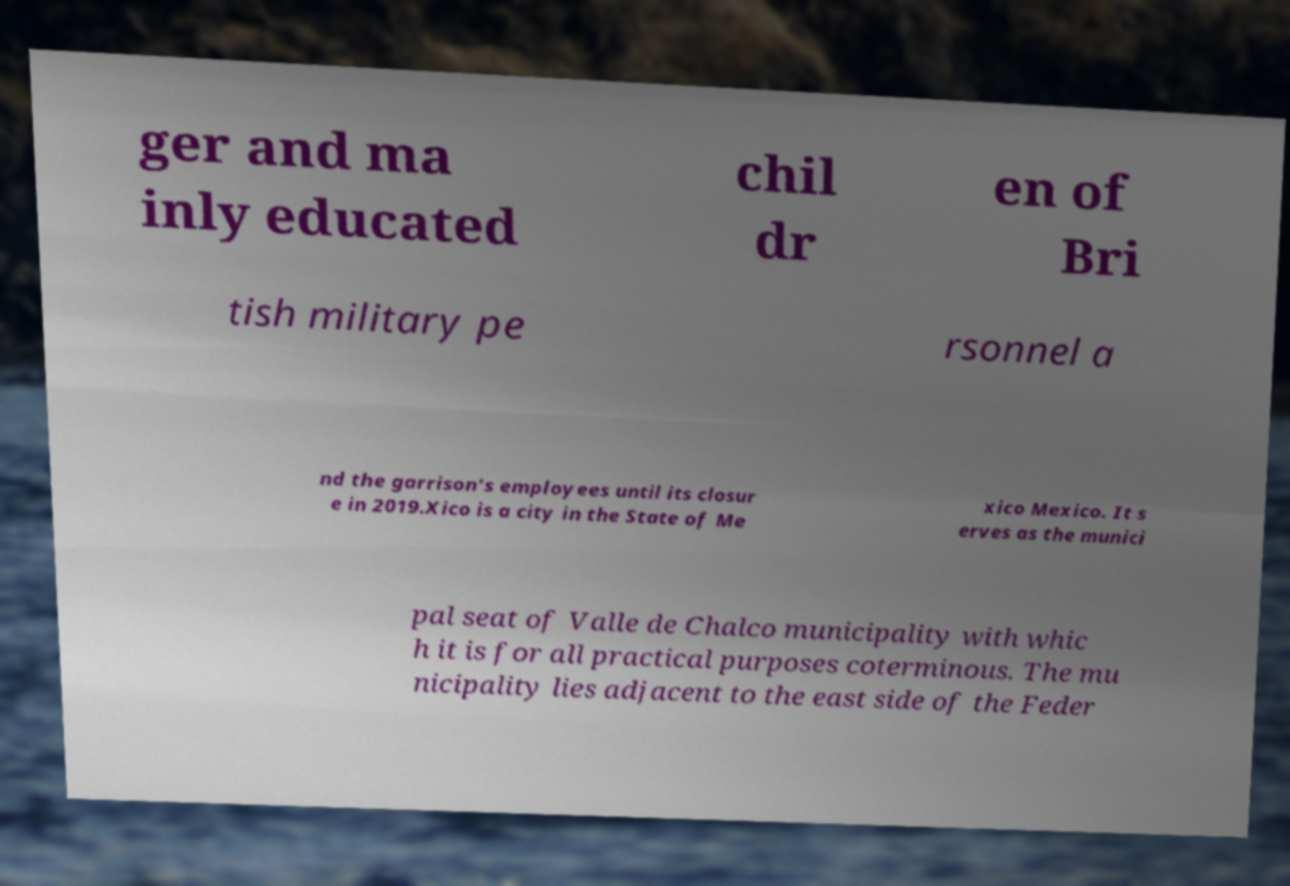Could you assist in decoding the text presented in this image and type it out clearly? ger and ma inly educated chil dr en of Bri tish military pe rsonnel a nd the garrison's employees until its closur e in 2019.Xico is a city in the State of Me xico Mexico. It s erves as the munici pal seat of Valle de Chalco municipality with whic h it is for all practical purposes coterminous. The mu nicipality lies adjacent to the east side of the Feder 